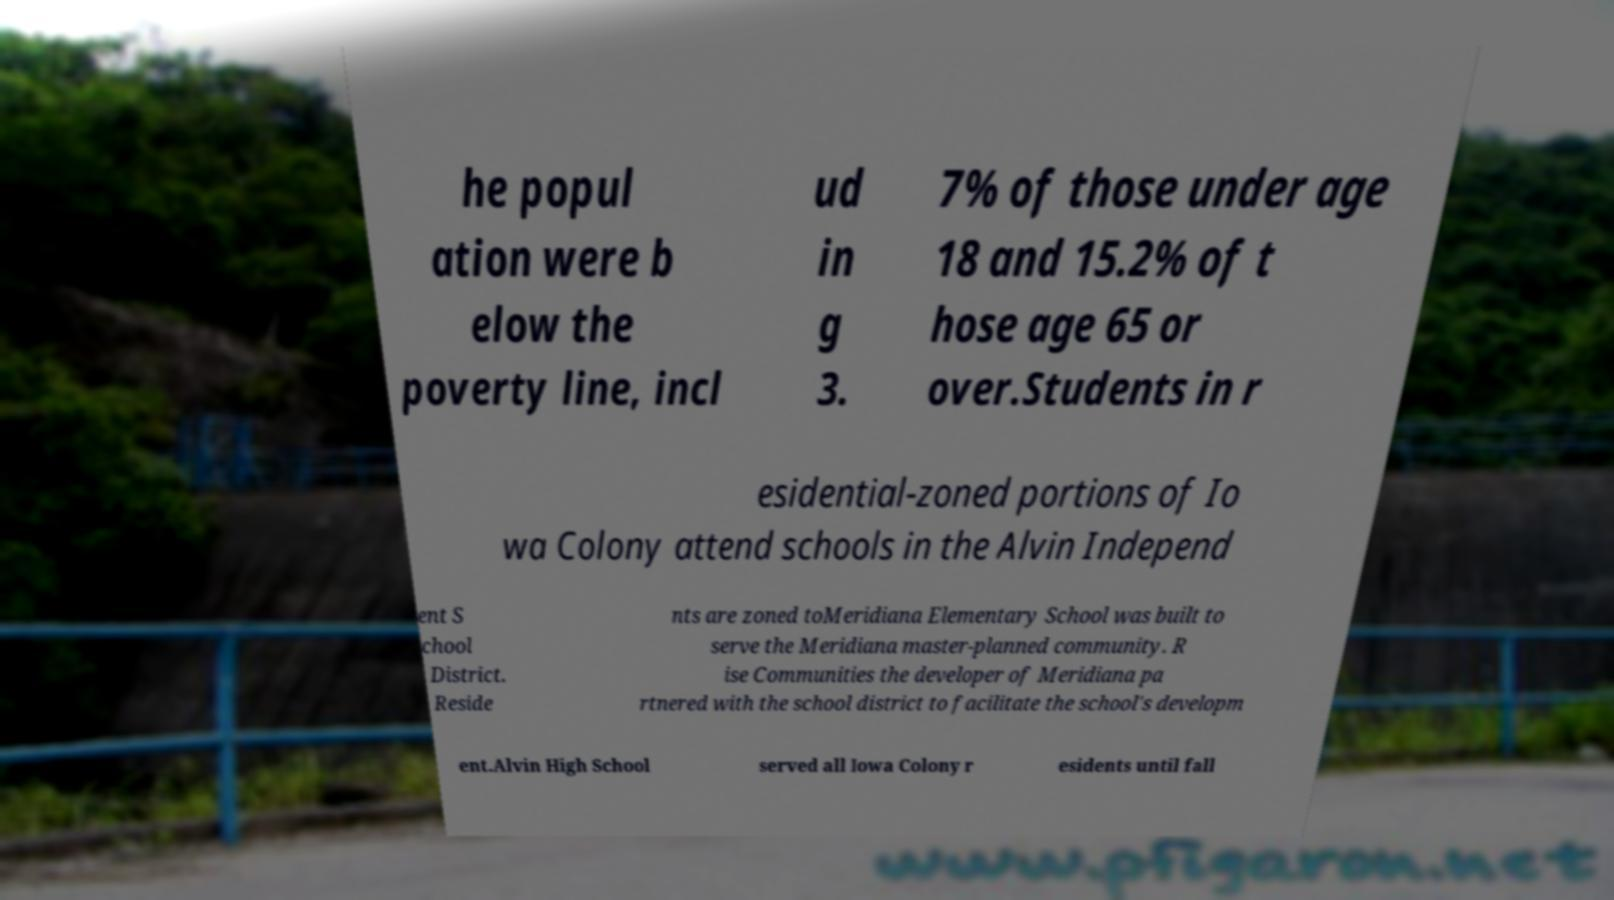Can you read and provide the text displayed in the image?This photo seems to have some interesting text. Can you extract and type it out for me? he popul ation were b elow the poverty line, incl ud in g 3. 7% of those under age 18 and 15.2% of t hose age 65 or over.Students in r esidential-zoned portions of Io wa Colony attend schools in the Alvin Independ ent S chool District. Reside nts are zoned toMeridiana Elementary School was built to serve the Meridiana master-planned community. R ise Communities the developer of Meridiana pa rtnered with the school district to facilitate the school's developm ent.Alvin High School served all Iowa Colony r esidents until fall 